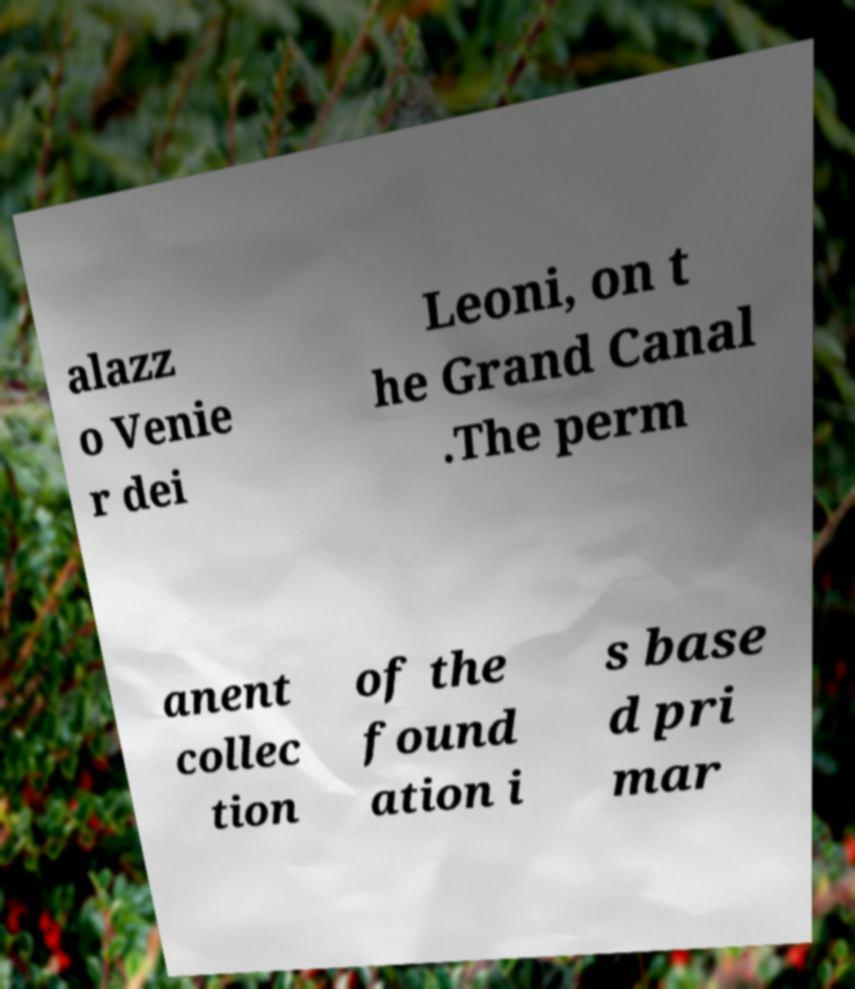For documentation purposes, I need the text within this image transcribed. Could you provide that? alazz o Venie r dei Leoni, on t he Grand Canal .The perm anent collec tion of the found ation i s base d pri mar 